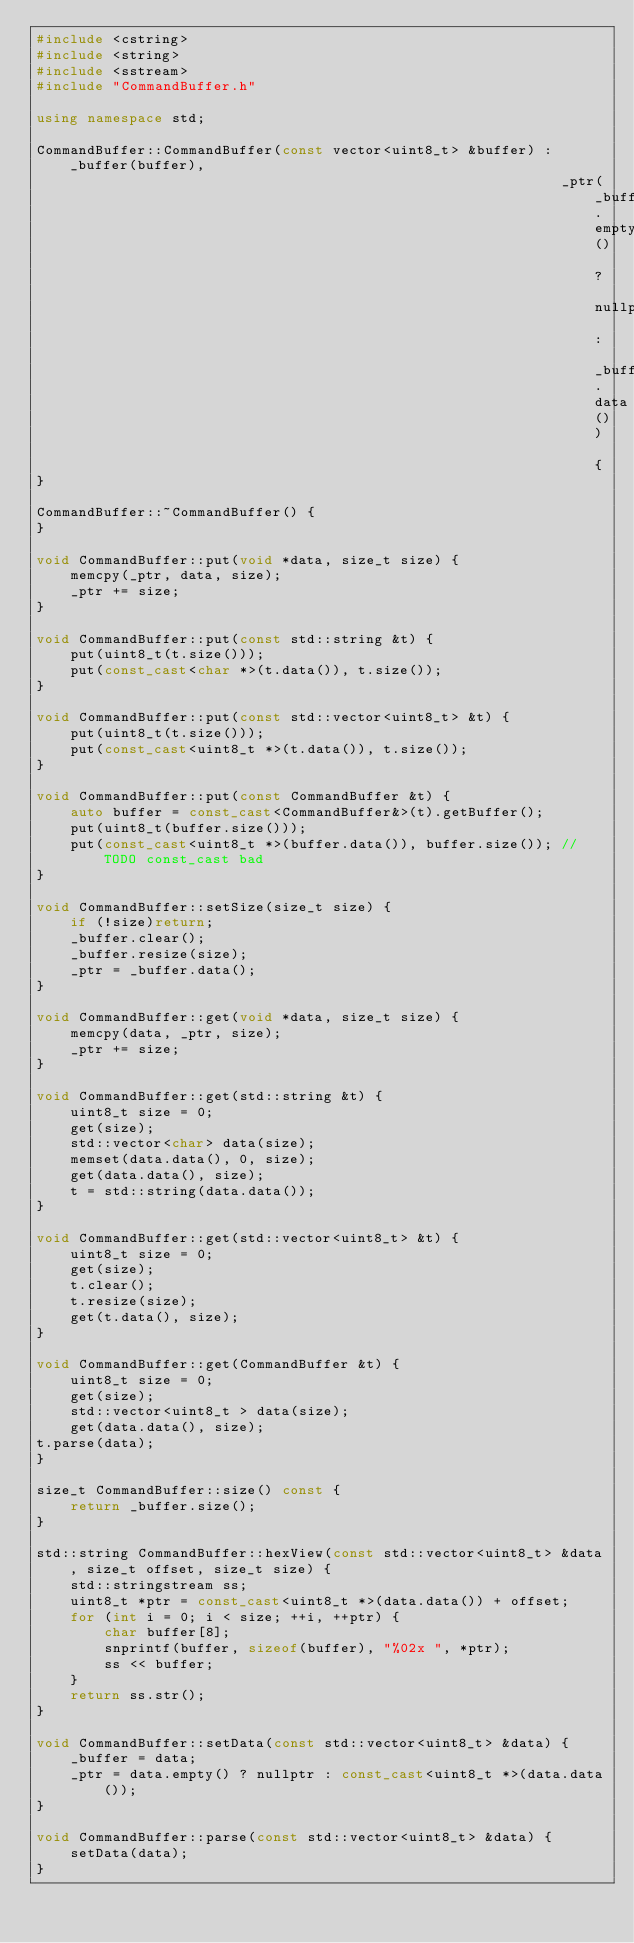<code> <loc_0><loc_0><loc_500><loc_500><_C++_>#include <cstring>
#include <string>
#include <sstream>
#include "CommandBuffer.h"

using namespace std;

CommandBuffer::CommandBuffer(const vector<uint8_t> &buffer) : _buffer(buffer),
                                                              _ptr(_buffer.empty() ? nullptr : _buffer.data()) {
}

CommandBuffer::~CommandBuffer() {
}

void CommandBuffer::put(void *data, size_t size) {
    memcpy(_ptr, data, size);
    _ptr += size;
}

void CommandBuffer::put(const std::string &t) {
    put(uint8_t(t.size()));
    put(const_cast<char *>(t.data()), t.size());
}

void CommandBuffer::put(const std::vector<uint8_t> &t) {
    put(uint8_t(t.size()));
    put(const_cast<uint8_t *>(t.data()), t.size());
}

void CommandBuffer::put(const CommandBuffer &t) {
    auto buffer = const_cast<CommandBuffer&>(t).getBuffer();
    put(uint8_t(buffer.size()));
    put(const_cast<uint8_t *>(buffer.data()), buffer.size()); // TODO const_cast bad
}

void CommandBuffer::setSize(size_t size) {
    if (!size)return;
    _buffer.clear();
    _buffer.resize(size);
    _ptr = _buffer.data();
}

void CommandBuffer::get(void *data, size_t size) {
    memcpy(data, _ptr, size);
    _ptr += size;
}

void CommandBuffer::get(std::string &t) {
    uint8_t size = 0;
    get(size);
    std::vector<char> data(size);
    memset(data.data(), 0, size);
    get(data.data(), size);
    t = std::string(data.data());
}

void CommandBuffer::get(std::vector<uint8_t> &t) {
    uint8_t size = 0;
    get(size);
    t.clear();
    t.resize(size);
    get(t.data(), size);
}

void CommandBuffer::get(CommandBuffer &t) {
    uint8_t size = 0;
    get(size);
    std::vector<uint8_t > data(size);
    get(data.data(), size);
t.parse(data);
}

size_t CommandBuffer::size() const {
    return _buffer.size();
}

std::string CommandBuffer::hexView(const std::vector<uint8_t> &data, size_t offset, size_t size) {
    std::stringstream ss;
    uint8_t *ptr = const_cast<uint8_t *>(data.data()) + offset;
    for (int i = 0; i < size; ++i, ++ptr) {
        char buffer[8];
        snprintf(buffer, sizeof(buffer), "%02x ", *ptr);
        ss << buffer;
    }
    return ss.str();
}

void CommandBuffer::setData(const std::vector<uint8_t> &data) {
    _buffer = data;
    _ptr = data.empty() ? nullptr : const_cast<uint8_t *>(data.data());
}

void CommandBuffer::parse(const std::vector<uint8_t> &data) {
    setData(data);
}


</code> 